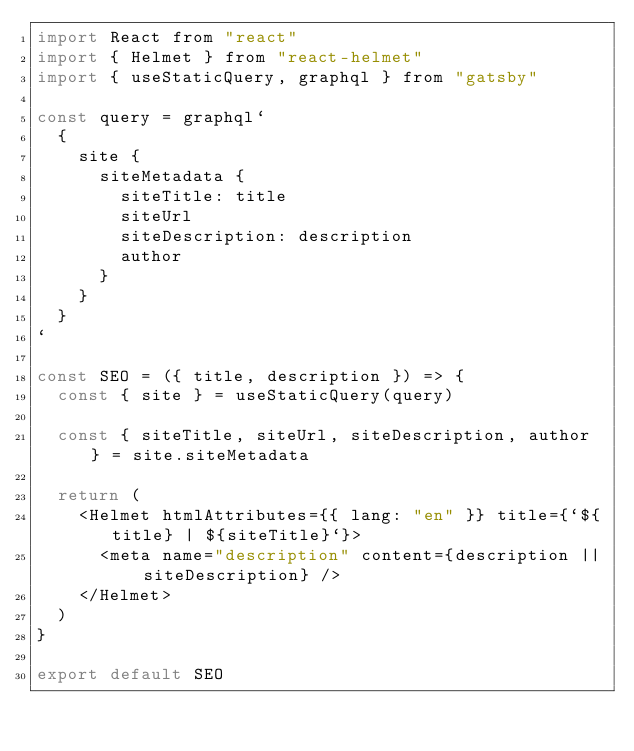<code> <loc_0><loc_0><loc_500><loc_500><_JavaScript_>import React from "react"
import { Helmet } from "react-helmet"
import { useStaticQuery, graphql } from "gatsby"

const query = graphql`
  {
    site {
      siteMetadata {
        siteTitle: title
        siteUrl
        siteDescription: description
        author
      }
    }
  }
`

const SEO = ({ title, description }) => {
  const { site } = useStaticQuery(query)

  const { siteTitle, siteUrl, siteDescription, author } = site.siteMetadata

  return (
    <Helmet htmlAttributes={{ lang: "en" }} title={`${title} | ${siteTitle}`}>
      <meta name="description" content={description || siteDescription} />
    </Helmet>
  )
}

export default SEO
</code> 